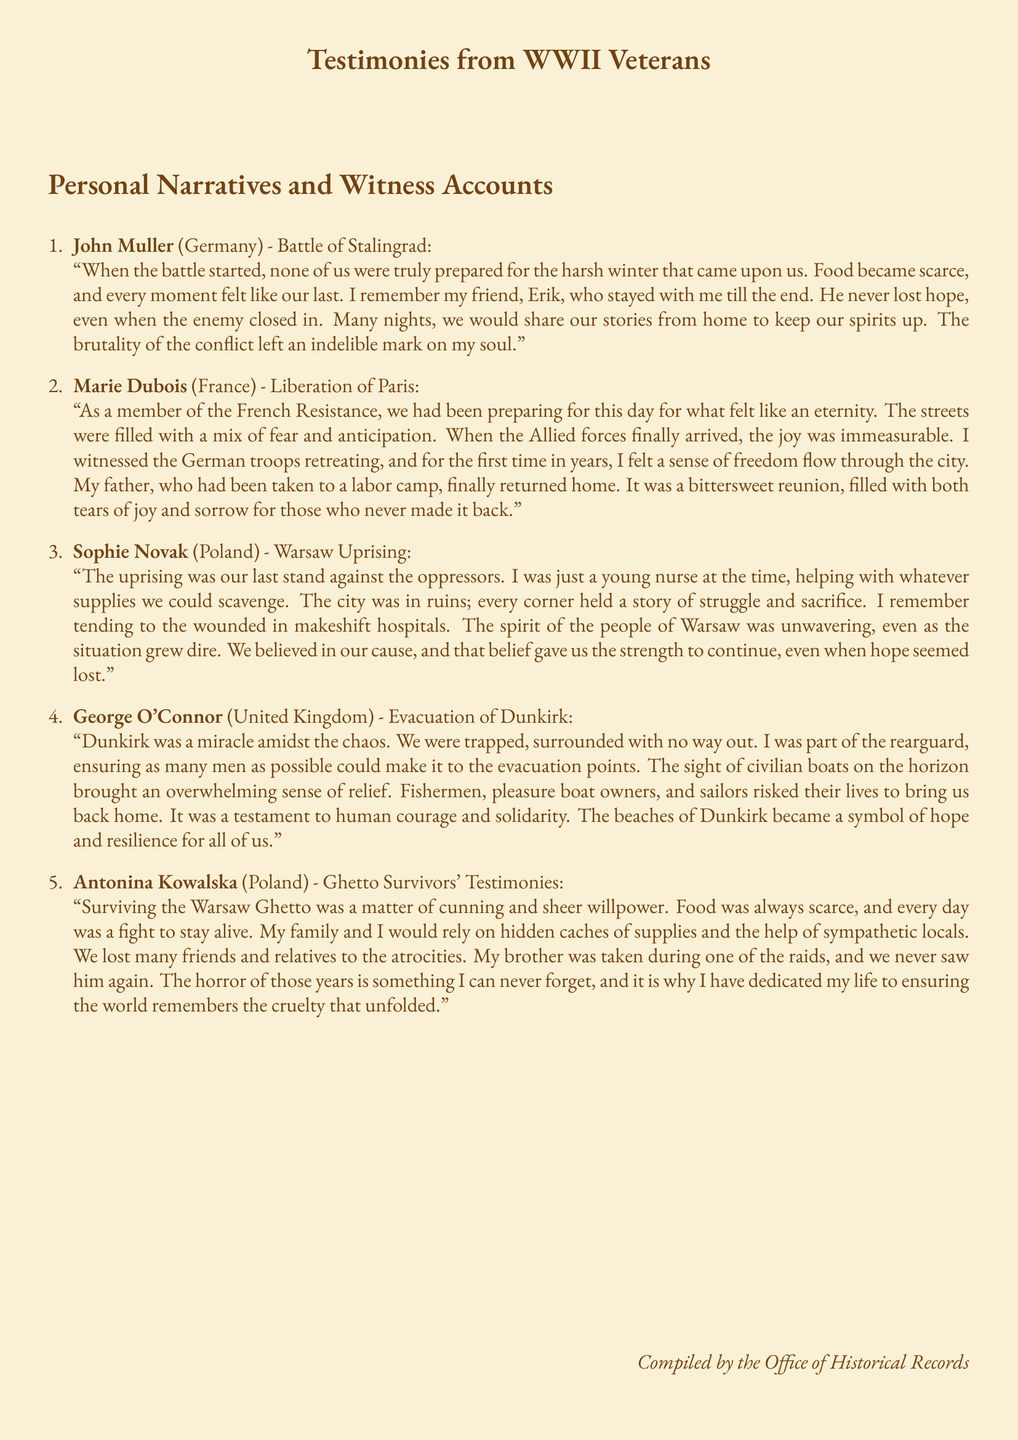What is the name of the veteran from Germany? The veteran from Germany is John Muller.
Answer: John Muller In which battle did John Muller participate? John Muller participated in the Battle of Stalingrad.
Answer: Battle of Stalingrad What year did Marie Dubois witness the liberation of Paris? The document does not specify the exact year, but it implies it was during WWII.
Answer: WWII Which country did Sophie Novak represent? Sophie Novak represented Poland.
Answer: Poland What event is George O'Connor associated with? George O'Connor is associated with the Evacuation of Dunkirk.
Answer: Evacuation of Dunkirk What does Antonina Kowalska emphasize in her testimony? Antonina Kowalska emphasizes ensuring the world remembers the cruelty that unfolded.
Answer: Remembering cruelty How did the people of Warsaw respond during the uprising? The people of Warsaw showed unwavering spirit, even as the situation grew dire.
Answer: Unwavering spirit What significant role did civilians play during Dunkirk? Civilians risked their lives to bring back soldiers home.
Answer: Risked their lives What kind of narrative is this document focused on? This document focuses on personal narratives and witness accounts.
Answer: Personal narratives 